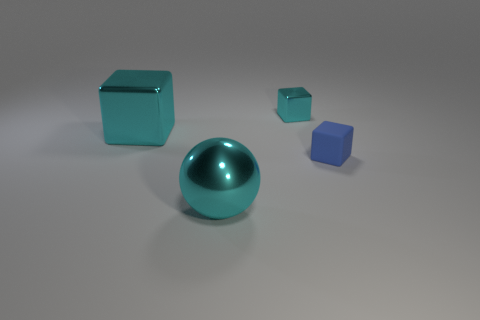Is there anything else that is made of the same material as the tiny blue thing?
Offer a very short reply. No. What is the size of the matte object?
Give a very brief answer. Small. How many cyan things are the same size as the matte cube?
Your answer should be very brief. 1. Is the big sphere the same color as the big metal cube?
Make the answer very short. Yes. Does the cube that is to the left of the tiny metal block have the same material as the big object in front of the matte cube?
Make the answer very short. Yes. Is the number of large metallic cylinders greater than the number of tiny blue matte blocks?
Provide a short and direct response. No. Is there any other thing of the same color as the large ball?
Your response must be concise. Yes. Are the large sphere and the small cyan object made of the same material?
Offer a very short reply. Yes. Are there fewer shiny blocks than large purple matte cylinders?
Give a very brief answer. No. The rubber block has what color?
Provide a short and direct response. Blue. 